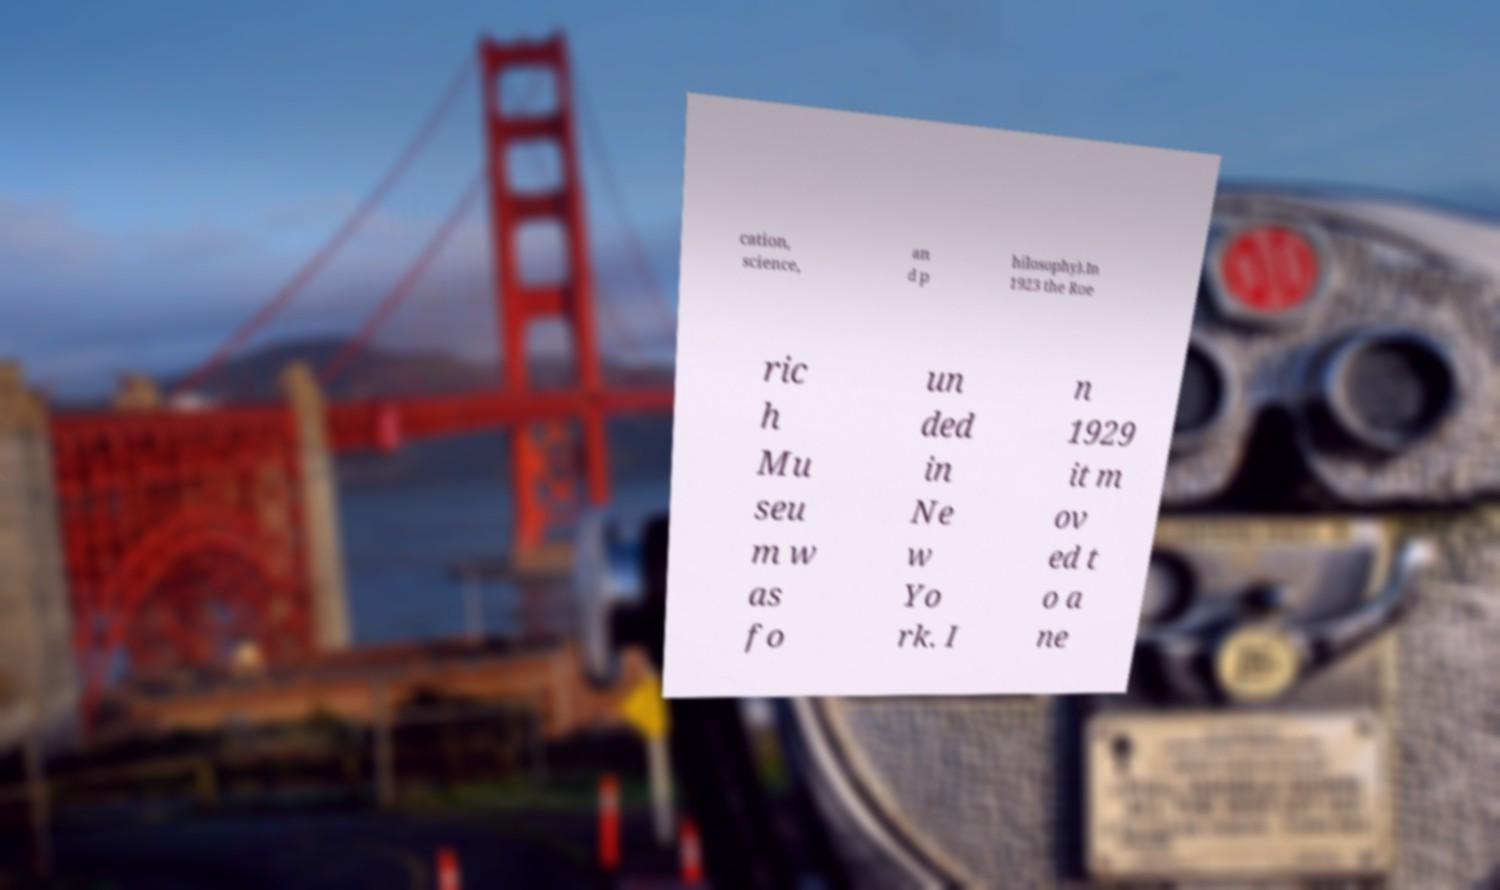Please read and relay the text visible in this image. What does it say? cation, science, an d p hilosophy).In 1923 the Roe ric h Mu seu m w as fo un ded in Ne w Yo rk. I n 1929 it m ov ed t o a ne 